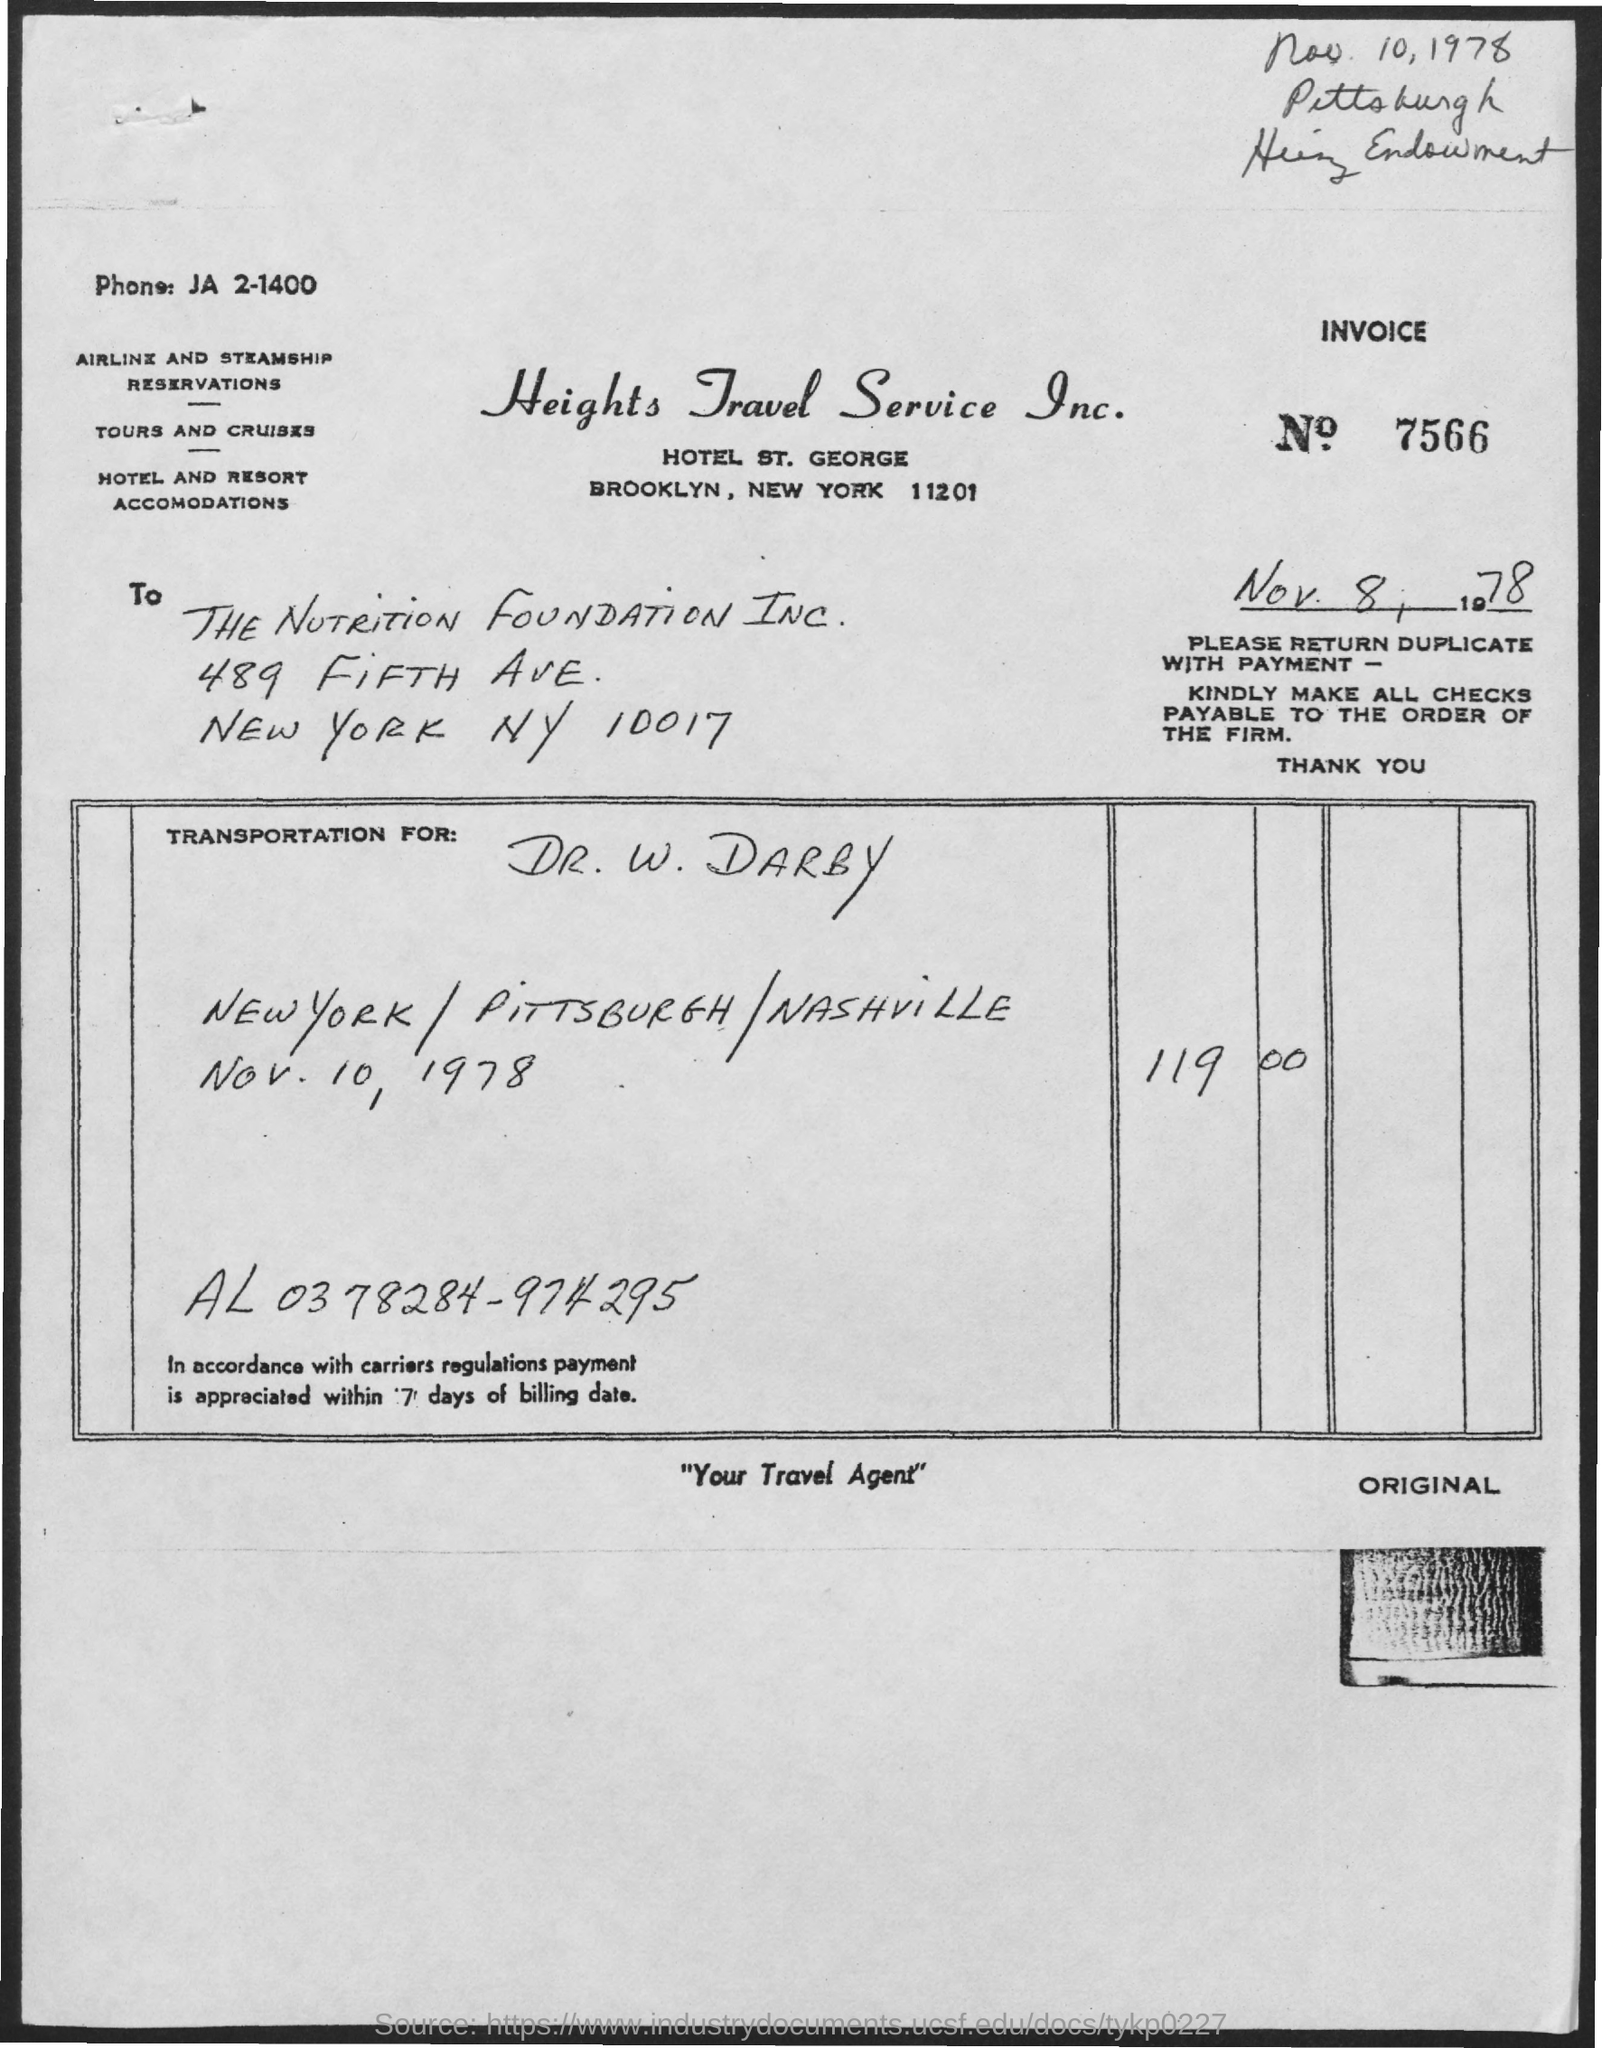List a handful of essential elements in this visual. Heights Travel Service Inc.'s phone number is JA 2-1400. The invoice is being raised by Heights Travel Service Inc. The invoice number mentioned in this document is 7566. The invoice amount for transportation on November 10, 1978, for Dr. W. DARBY was $119.00. The invoice is addressed to THE NUTRITION FOUNDATION INC. 